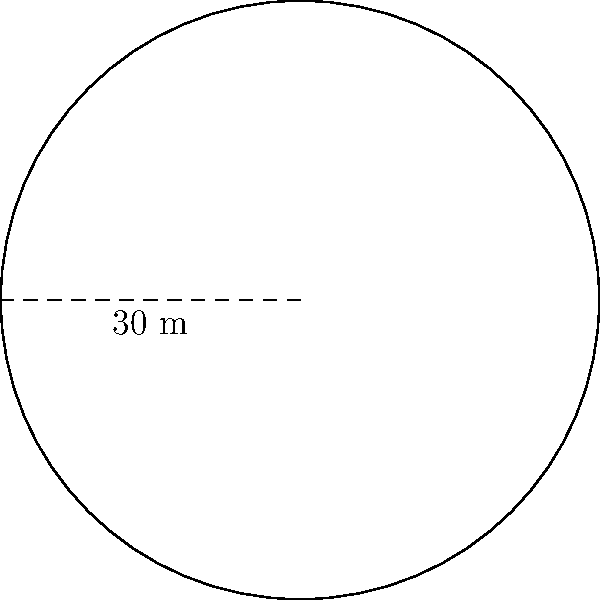A circular storage facility is being considered for sale. The radius of the facility is 30 meters. If the current market value is $500 per square meter, what is the estimated value of the entire facility? To solve this problem, we need to follow these steps:

1. Calculate the area of the circular storage facility:
   The formula for the area of a circle is $A = \pi r^2$, where $r$ is the radius.
   
   $A = \pi \times 30^2 = 900\pi$ square meters

2. Convert the area to a numeric value (rounded to 2 decimal places):
   $A \approx 2,827.43$ square meters

3. Calculate the estimated value:
   Value = Area × Price per square meter
   $Value = 2,827.43 \times \$500 = \$1,413,715$

Therefore, the estimated value of the entire facility is $1,413,715.
Answer: $1,413,715 